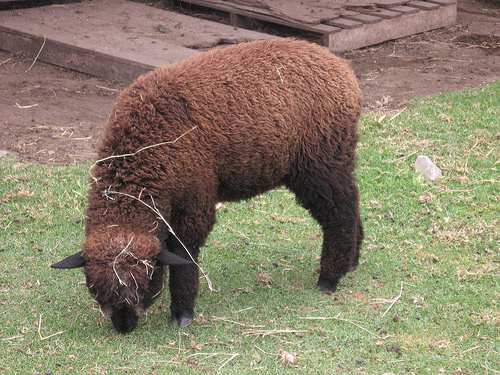What is the alpaca doing in the image, and why might it be doing that? The alpaca in the image appears to be grazing or searching for food on the ground. This behavior is natural as alpacas are herbivores and spend much of their time grazing on grass, herbs, and other vegetation, which is essential for their diet. 